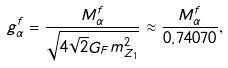Convert formula to latex. <formula><loc_0><loc_0><loc_500><loc_500>g ^ { f } _ { \alpha } = \frac { M ^ { f } _ { \alpha } } { \sqrt { 4 \sqrt { 2 } G _ { F } m ^ { 2 } _ { Z _ { 1 } } } } \approx \frac { M ^ { f } _ { \alpha } } { 0 . 7 4 0 7 0 } ,</formula> 